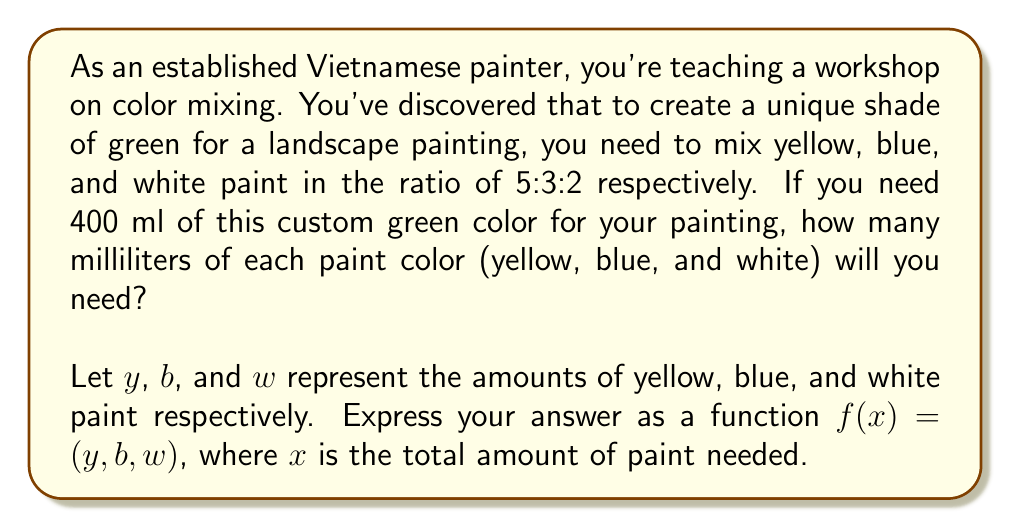Can you solve this math problem? To solve this problem, we'll follow these steps:

1) First, let's establish the ratio of the paints:
   Yellow : Blue : White = 5 : 3 : 2

2) The sum of these parts represents the whole mixture:
   $5 + 3 + 2 = 10$ parts total

3) We can express each color as a fraction of the whole:
   Yellow: $\frac{5}{10}$ of the total
   Blue: $\frac{3}{10}$ of the total
   White: $\frac{2}{10}$ of the total

4) Now, let's create a function $f(x)$ where $x$ is the total amount of paint needed:
   $f(x) = (y, b, w)$
   where:
   $y = \frac{5}{10}x$
   $b = \frac{3}{10}x$
   $w = \frac{2}{10}x$

5) For this specific case, we need 400 ml of paint in total, so $x = 400$:
   $y = \frac{5}{10} * 400 = 200$ ml of yellow
   $b = \frac{3}{10} * 400 = 120$ ml of blue
   $w = \frac{2}{10} * 400 = 80$ ml of white

Therefore, the function $f(x) = (\frac{5}{10}x, \frac{3}{10}x, \frac{2}{10}x)$ gives us the amount of yellow, blue, and white paint needed for any total amount $x$ of the custom green color.
Answer: $f(x) = (\frac{5}{10}x, \frac{3}{10}x, \frac{2}{10}x)$

For 400 ml of custom green: $f(400) = (200, 120, 80)$ 